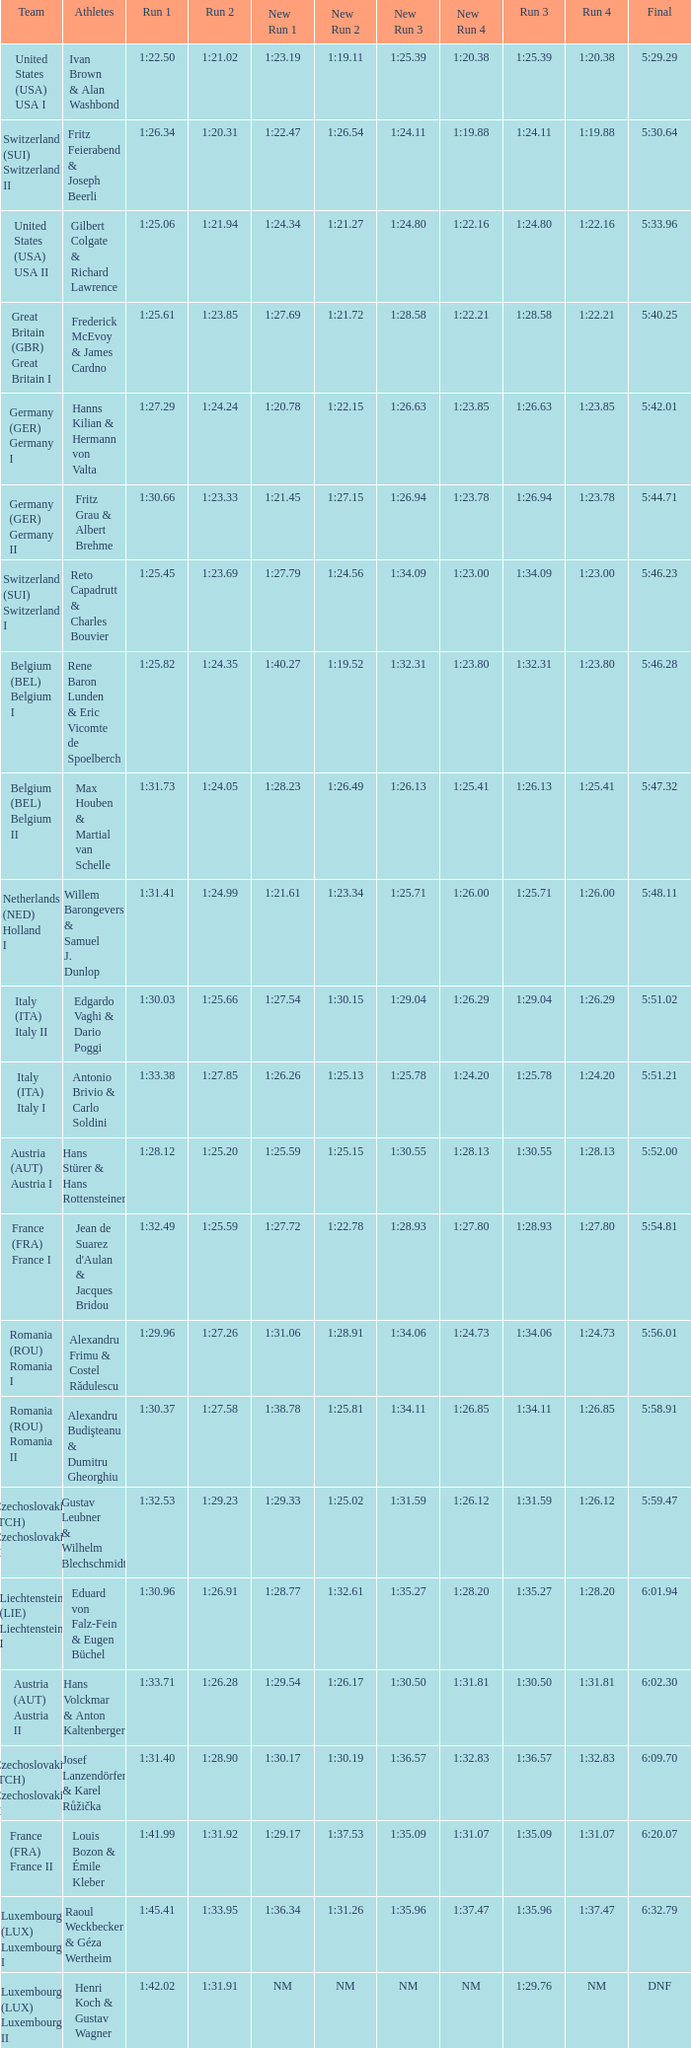Can you give me this table as a dict? {'header': ['Team', 'Athletes', 'Run 1', 'Run 2', 'New Run 1', 'New Run 2', 'New Run 3', 'New Run 4', 'Run 3', 'Run 4', 'Final'], 'rows': [['United States (USA) USA I', 'Ivan Brown & Alan Washbond', '1:22.50', '1:21.02', '1:23.19', '1:19.11', '1:25.39', '1:20.38', '1:25.39', '1:20.38', '5:29.29'], ['Switzerland (SUI) Switzerland II', 'Fritz Feierabend & Joseph Beerli', '1:26.34', '1:20.31', '1:22.47', '1:26.54', '1:24.11', '1:19.88', '1:24.11', '1:19.88', '5:30.64'], ['United States (USA) USA II', 'Gilbert Colgate & Richard Lawrence', '1:25.06', '1:21.94', '1:24.34', '1:21.27', '1:24.80', '1:22.16', '1:24.80', '1:22.16', '5:33.96'], ['Great Britain (GBR) Great Britain I', 'Frederick McEvoy & James Cardno', '1:25.61', '1:23.85', '1:27.69', '1:21.72', '1:28.58', '1:22.21', '1:28.58', '1:22.21', '5:40.25'], ['Germany (GER) Germany I', 'Hanns Kilian & Hermann von Valta', '1:27.29', '1:24.24', '1:20.78', '1:22.15', '1:26.63', '1:23.85', '1:26.63', '1:23.85', '5:42.01'], ['Germany (GER) Germany II', 'Fritz Grau & Albert Brehme', '1:30.66', '1:23.33', '1:21.45', '1:27.15', '1:26.94', '1:23.78', '1:26.94', '1:23.78', '5:44.71'], ['Switzerland (SUI) Switzerland I', 'Reto Capadrutt & Charles Bouvier', '1:25.45', '1:23.69', '1:27.79', '1:24.56', '1:34.09', '1:23.00', '1:34.09', '1:23.00', '5:46.23'], ['Belgium (BEL) Belgium I', 'Rene Baron Lunden & Eric Vicomte de Spoelberch', '1:25.82', '1:24.35', '1:40.27', '1:19.52', '1:32.31', '1:23.80', '1:32.31', '1:23.80', '5:46.28'], ['Belgium (BEL) Belgium II', 'Max Houben & Martial van Schelle', '1:31.73', '1:24.05', '1:28.23', '1:26.49', '1:26.13', '1:25.41', '1:26.13', '1:25.41', '5:47.32'], ['Netherlands (NED) Holland I', 'Willem Barongevers & Samuel J. Dunlop', '1:31.41', '1:24.99', '1:21.61', '1:23.34', '1:25.71', '1:26.00', '1:25.71', '1:26.00', '5:48.11'], ['Italy (ITA) Italy II', 'Edgardo Vaghi & Dario Poggi', '1:30.03', '1:25.66', '1:27.54', '1:30.15', '1:29.04', '1:26.29', '1:29.04', '1:26.29', '5:51.02'], ['Italy (ITA) Italy I', 'Antonio Brivio & Carlo Soldini', '1:33.38', '1:27.85', '1:26.26', '1:25.13', '1:25.78', '1:24.20', '1:25.78', '1:24.20', '5:51.21'], ['Austria (AUT) Austria I', 'Hans Stürer & Hans Rottensteiner', '1:28.12', '1:25.20', '1:25.59', '1:25.15', '1:30.55', '1:28.13', '1:30.55', '1:28.13', '5:52.00'], ['France (FRA) France I', "Jean de Suarez d'Aulan & Jacques Bridou", '1:32.49', '1:25.59', '1:27.72', '1:22.78', '1:28.93', '1:27.80', '1:28.93', '1:27.80', '5:54.81'], ['Romania (ROU) Romania I', 'Alexandru Frimu & Costel Rădulescu', '1:29.96', '1:27.26', '1:31.06', '1:28.91', '1:34.06', '1:24.73', '1:34.06', '1:24.73', '5:56.01'], ['Romania (ROU) Romania II', 'Alexandru Budişteanu & Dumitru Gheorghiu', '1:30.37', '1:27.58', '1:38.78', '1:25.81', '1:34.11', '1:26.85', '1:34.11', '1:26.85', '5:58.91'], ['Czechoslovakia (TCH) Czechoslovakia II', 'Gustav Leubner & Wilhelm Blechschmidt', '1:32.53', '1:29.23', '1:29.33', '1:25.02', '1:31.59', '1:26.12', '1:31.59', '1:26.12', '5:59.47'], ['Liechtenstein (LIE) Liechtenstein I', 'Eduard von Falz-Fein & Eugen Büchel', '1:30.96', '1:26.91', '1:28.77', '1:32.61', '1:35.27', '1:28.20', '1:35.27', '1:28.20', '6:01.94'], ['Austria (AUT) Austria II', 'Hans Volckmar & Anton Kaltenberger', '1:33.71', '1:26.28', '1:29.54', '1:26.17', '1:30.50', '1:31.81', '1:30.50', '1:31.81', '6:02.30'], ['Czechoslovakia (TCH) Czechoslovakia II', 'Josef Lanzendörfer & Karel Růžička', '1:31.40', '1:28.90', '1:30.17', '1:30.19', '1:36.57', '1:32.83', '1:36.57', '1:32.83', '6:09.70'], ['France (FRA) France II', 'Louis Bozon & Émile Kleber', '1:41.99', '1:31.92', '1:29.17', '1:37.53', '1:35.09', '1:31.07', '1:35.09', '1:31.07', '6:20.07'], ['Luxembourg (LUX) Luxembourg I', 'Raoul Weckbecker & Géza Wertheim', '1:45.41', '1:33.95', '1:36.34', '1:31.26', '1:35.96', '1:37.47', '1:35.96', '1:37.47', '6:32.79'], ['Luxembourg (LUX) Luxembourg II', 'Henri Koch & Gustav Wagner', '1:42.02', '1:31.91', 'NM', 'NM', 'NM', 'NM', '1:29.76', 'NM', 'DNF']]} Which Final has a Run 2 of 1:27.58? 5:58.91. 